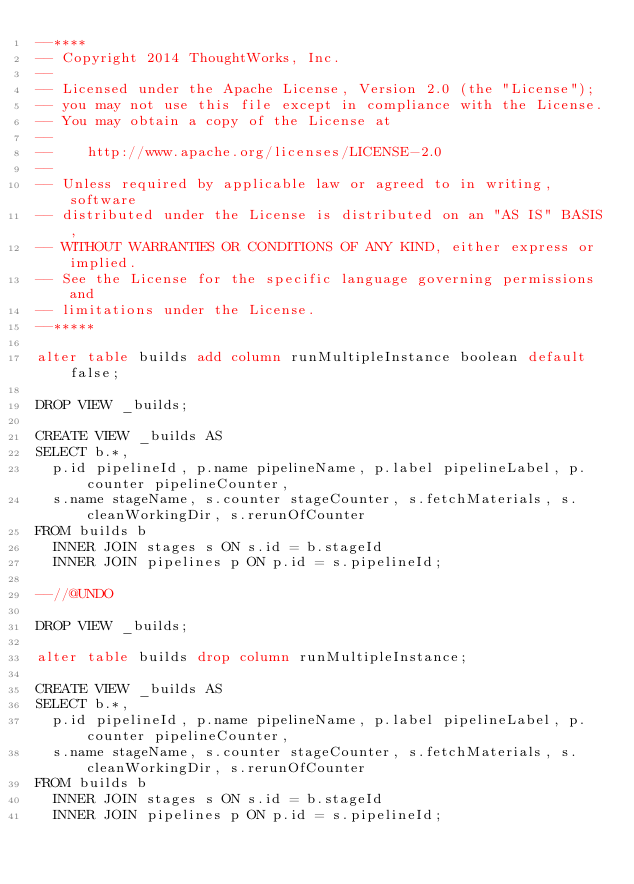Convert code to text. <code><loc_0><loc_0><loc_500><loc_500><_SQL_>--****
-- Copyright 2014 ThoughtWorks, Inc.
--
-- Licensed under the Apache License, Version 2.0 (the "License");
-- you may not use this file except in compliance with the License.
-- You may obtain a copy of the License at
--
--    http://www.apache.org/licenses/LICENSE-2.0
--
-- Unless required by applicable law or agreed to in writing, software
-- distributed under the License is distributed on an "AS IS" BASIS,
-- WITHOUT WARRANTIES OR CONDITIONS OF ANY KIND, either express or implied.
-- See the License for the specific language governing permissions and
-- limitations under the License.
--*****

alter table builds add column runMultipleInstance boolean default false;

DROP VIEW _builds;

CREATE VIEW _builds AS
SELECT b.*,
  p.id pipelineId, p.name pipelineName, p.label pipelineLabel, p.counter pipelineCounter,
  s.name stageName, s.counter stageCounter, s.fetchMaterials, s.cleanWorkingDir, s.rerunOfCounter
FROM builds b
  INNER JOIN stages s ON s.id = b.stageId
  INNER JOIN pipelines p ON p.id = s.pipelineId;

--//@UNDO

DROP VIEW _builds;

alter table builds drop column runMultipleInstance;

CREATE VIEW _builds AS
SELECT b.*,
  p.id pipelineId, p.name pipelineName, p.label pipelineLabel, p.counter pipelineCounter,
  s.name stageName, s.counter stageCounter, s.fetchMaterials, s.cleanWorkingDir, s.rerunOfCounter
FROM builds b
  INNER JOIN stages s ON s.id = b.stageId
  INNER JOIN pipelines p ON p.id = s.pipelineId;
</code> 